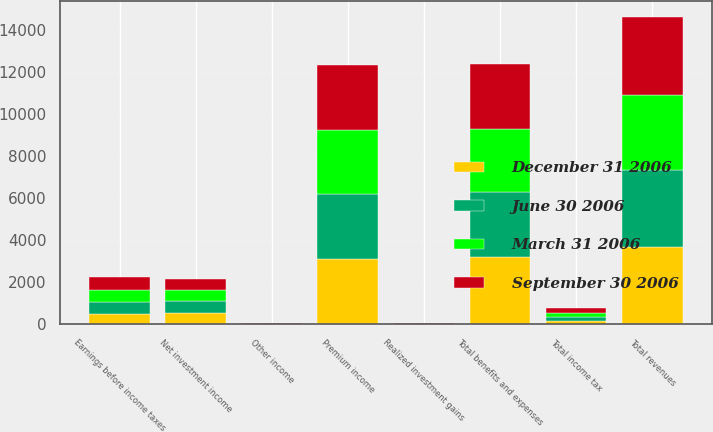Convert chart. <chart><loc_0><loc_0><loc_500><loc_500><stacked_bar_chart><ecel><fcel>Premium income<fcel>Net investment income<fcel>Realized investment gains<fcel>Other income<fcel>Total revenues<fcel>Total benefits and expenses<fcel>Earnings before income taxes<fcel>Total income tax<nl><fcel>March 31 2006<fcel>3005<fcel>524<fcel>14<fcel>16<fcel>3559<fcel>2984<fcel>575<fcel>200<nl><fcel>September 30 2006<fcel>3093<fcel>542<fcel>50<fcel>12<fcel>3697<fcel>3073<fcel>624<fcel>216<nl><fcel>June 30 2006<fcel>3102<fcel>548<fcel>11<fcel>11<fcel>3672<fcel>3115<fcel>557<fcel>190<nl><fcel>December 31 2006<fcel>3114<fcel>557<fcel>5<fcel>11<fcel>3687<fcel>3180<fcel>507<fcel>175<nl></chart> 